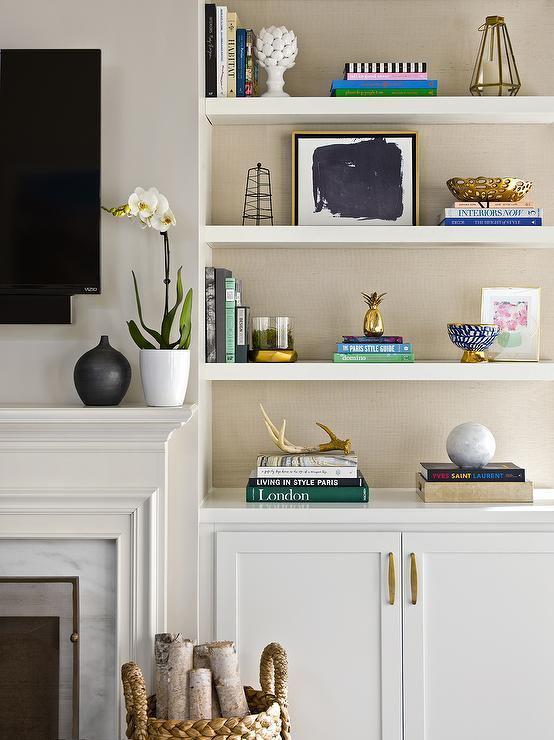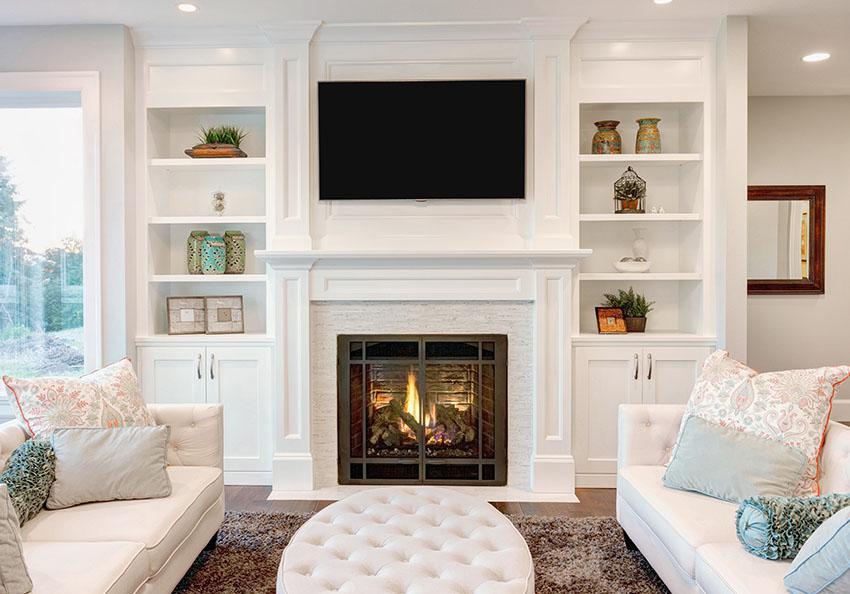The first image is the image on the left, the second image is the image on the right. For the images displayed, is the sentence "A television hangs over the mantle in the image on the left." factually correct? Answer yes or no. Yes. 